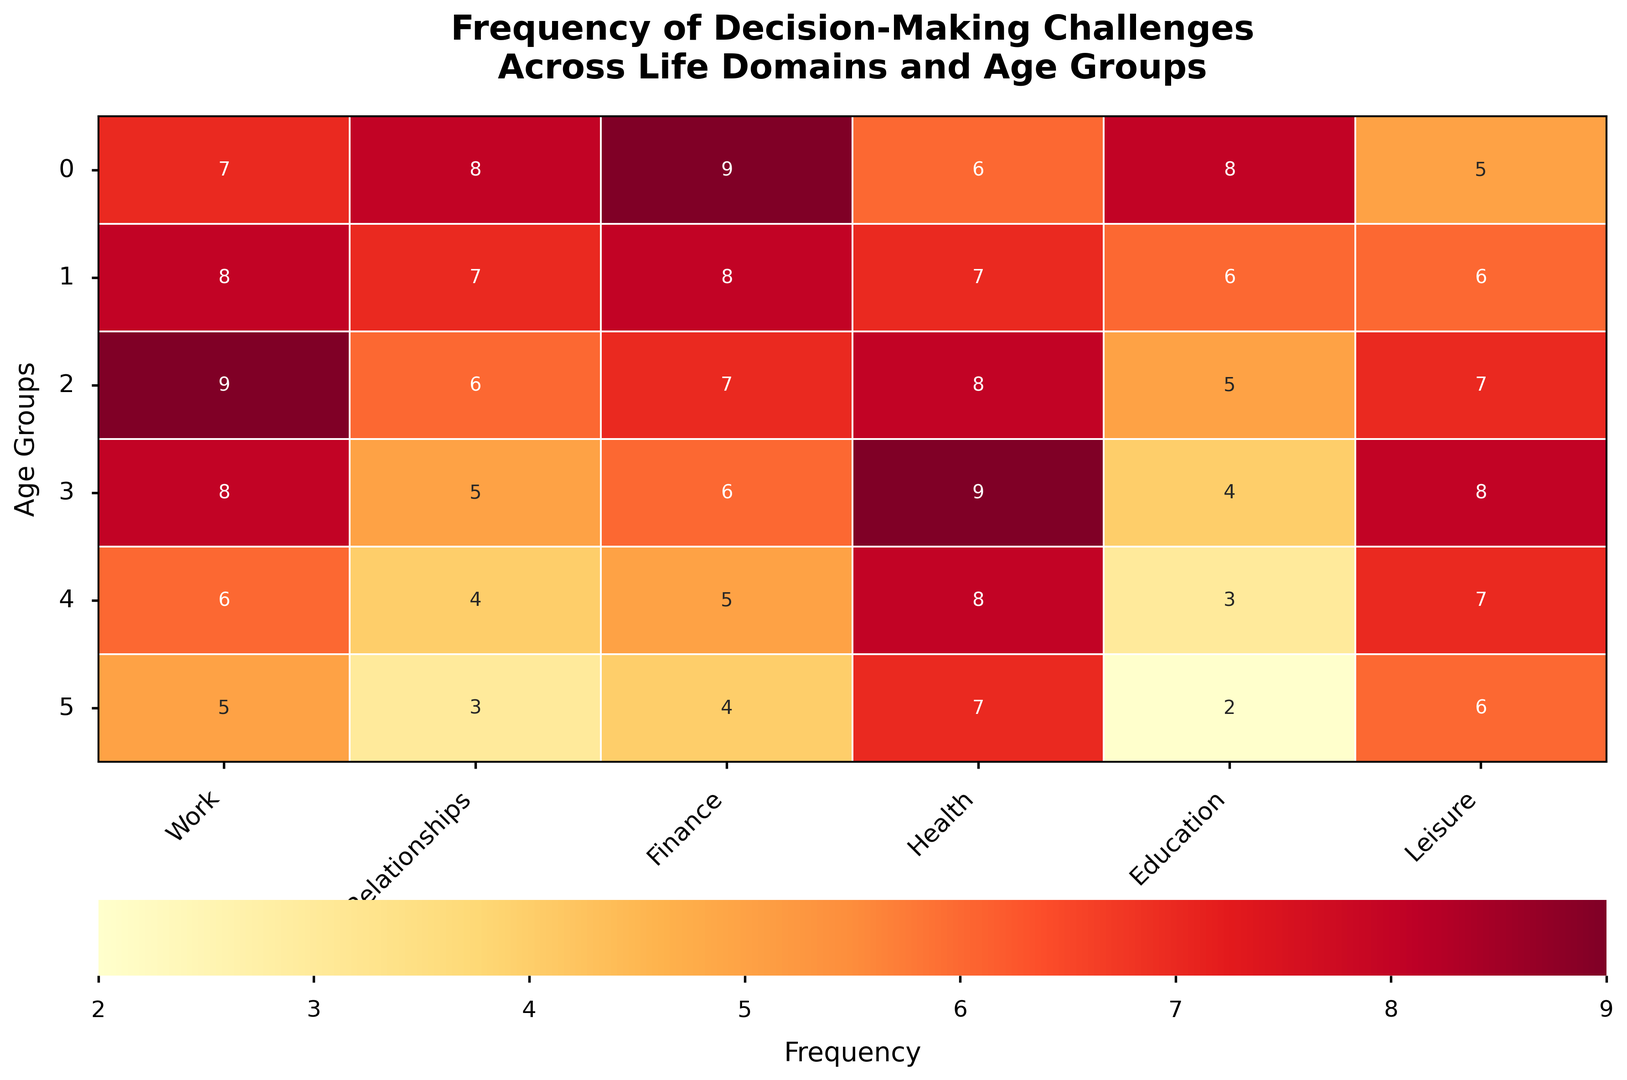What's the most frequent decision-making challenge for the 18-25 age group? The heatmap shows that the highest value in the row for the 18-25 age group is 9 in the Finance column.
Answer: Finance How does the frequency of decision-making challenges in health compare between ages 36-45 and 66+? For health, the value for 36-45 is 8, and for 66+ it's 7. So, the frequency for 36-45 is slightly higher than for 66+.
Answer: 36-45 > 66+ What is the average frequency of decision-making challenges across all domains for the 26-35 age group? Summing the frequency values for the 26-35 age group (8, 7, 8, 7, 6, 6) gives 42. Dividing by the number of domains (6) results in an average of 7.
Answer: 7 Which age group has the lowest frequency of decision-making challenges in relationships? By examining the Relationships column, the lowest value, 3, is observed in the 66+ age group.
Answer: 66+ Are decision-making challenges in leisure more common among 46-55 or 18-25 age groups? The heatmap shows the values for leisure as 8 for 46-55 and 5 for 18-25. Hence, it is more common in the 46-55 age group.
Answer: 46-55 What is the sum of decision-making challenges for the age groups 56-65 and 66+ in the domain of education? Education values are 3 for 56-65 and 2 for 66+. Summing these values gives a total of 5.
Answer: 5 How does the frequency of decision-making challenges in finance change from the 18-25 age group to the 66+ age group? The values for finance across these age groups decline from 9 for 18-25 to 4 for 66+, showing a downward trend.
Answer: Decreases Which domain has the highest frequency of decision-making challenges for the age group 36-45? In the 36-45 age group row, the highest value is 9 in the Work column.
Answer: Work Is the frequency of decision-making challenges in health equal for the age groups 46-55 and 56-65? The value for health is 9 for the 46-55 age group and 8 for the 56-65 age group, indicating they are not equal.
Answer: No What is the average frequency of decision-making challenges in the work domain across all age groups? Summing all the work domain values (7+8+9+8+6+5) gives 43. Dividing by the number of age groups (6) results in an average of 7.17 (rounded to 2 decimal places).
Answer: 7.17 